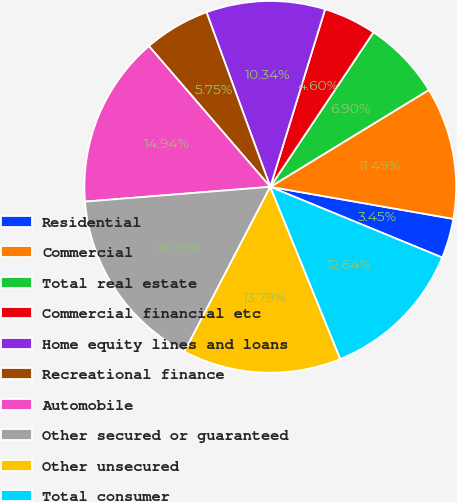<chart> <loc_0><loc_0><loc_500><loc_500><pie_chart><fcel>Residential<fcel>Commercial<fcel>Total real estate<fcel>Commercial financial etc<fcel>Home equity lines and loans<fcel>Recreational finance<fcel>Automobile<fcel>Other secured or guaranteed<fcel>Other unsecured<fcel>Total consumer<nl><fcel>3.45%<fcel>11.49%<fcel>6.9%<fcel>4.6%<fcel>10.34%<fcel>5.75%<fcel>14.94%<fcel>16.09%<fcel>13.79%<fcel>12.64%<nl></chart> 